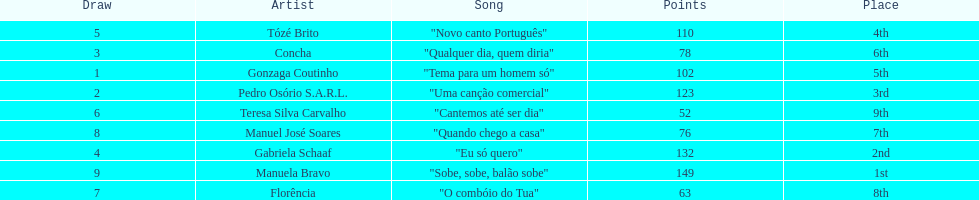What is the total amount of points for florencia? 63. 